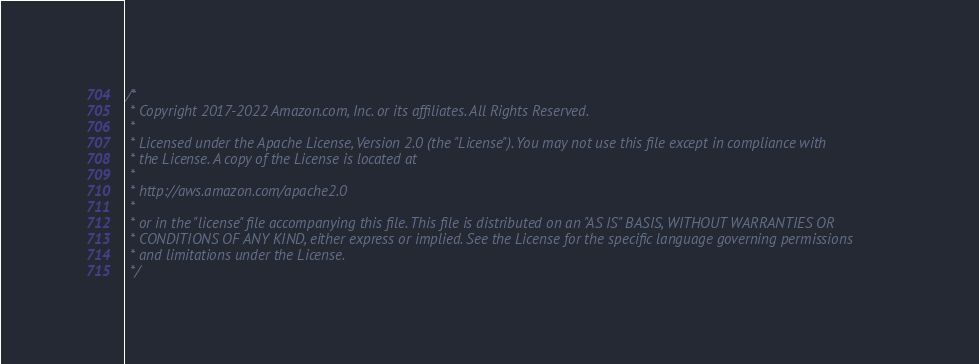Convert code to text. <code><loc_0><loc_0><loc_500><loc_500><_Java_>/*
 * Copyright 2017-2022 Amazon.com, Inc. or its affiliates. All Rights Reserved.
 * 
 * Licensed under the Apache License, Version 2.0 (the "License"). You may not use this file except in compliance with
 * the License. A copy of the License is located at
 * 
 * http://aws.amazon.com/apache2.0
 * 
 * or in the "license" file accompanying this file. This file is distributed on an "AS IS" BASIS, WITHOUT WARRANTIES OR
 * CONDITIONS OF ANY KIND, either express or implied. See the License for the specific language governing permissions
 * and limitations under the License.
 */</code> 